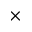<formula> <loc_0><loc_0><loc_500><loc_500>\times</formula> 